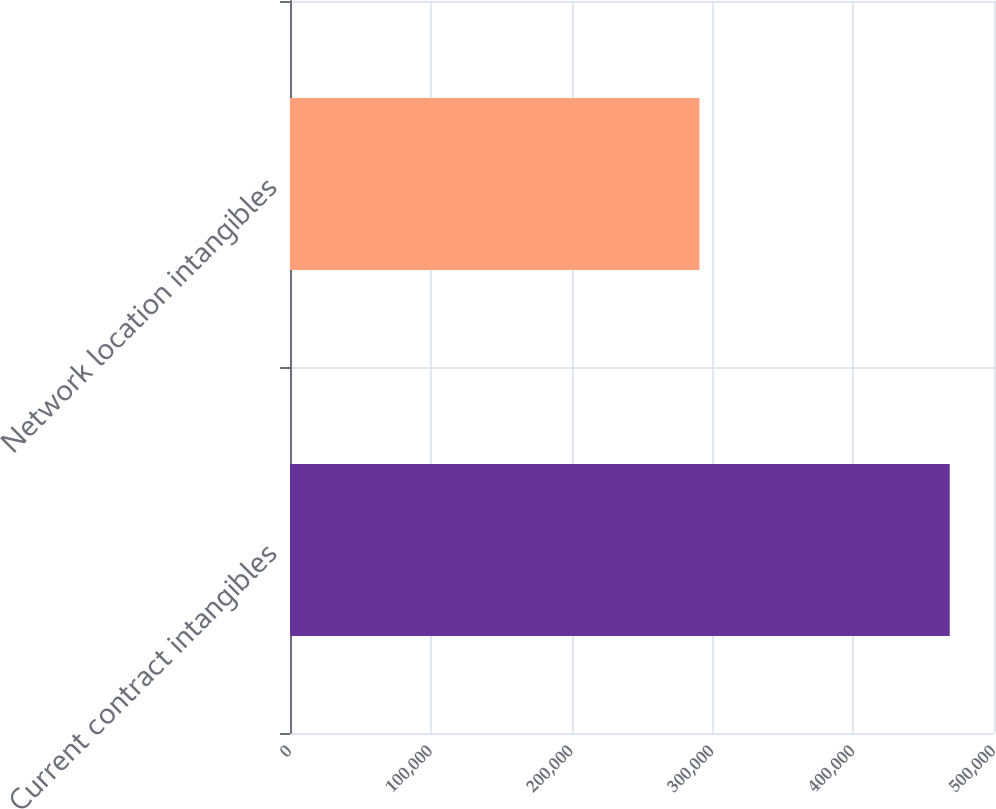Convert chart to OTSL. <chart><loc_0><loc_0><loc_500><loc_500><bar_chart><fcel>Current contract intangibles<fcel>Network location intangibles<nl><fcel>468561<fcel>290768<nl></chart> 